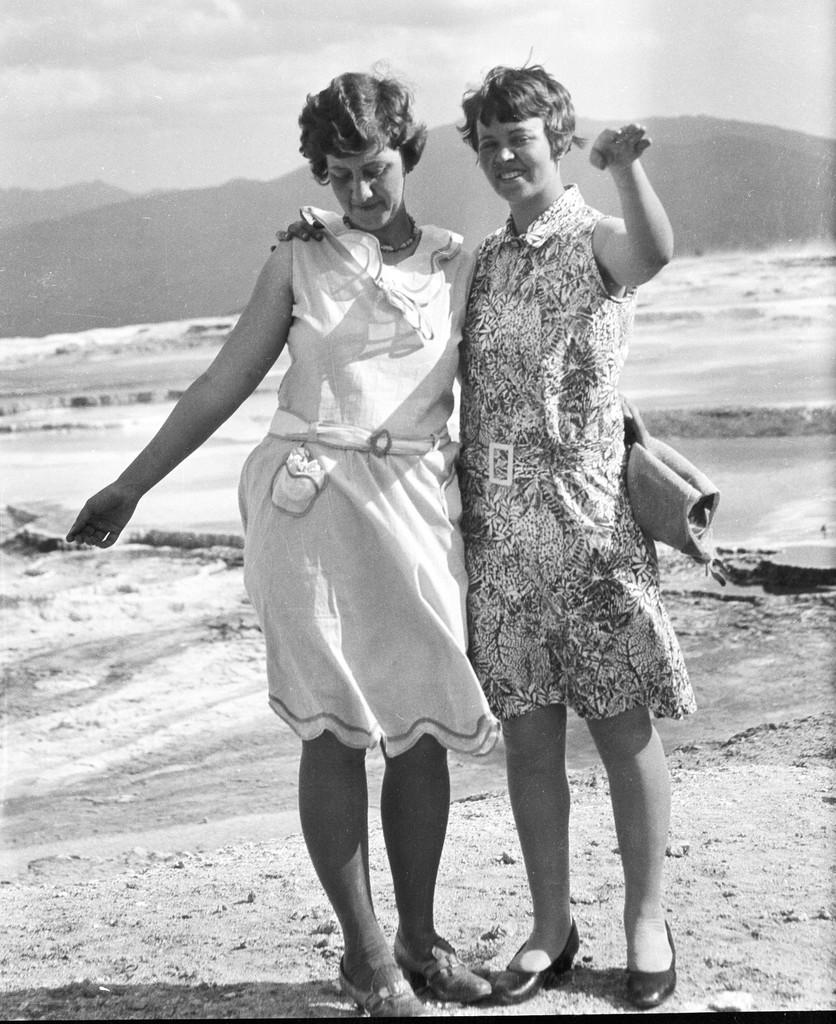How many people are in the image? There are two ladies standing in the center of the image. What can be seen in the background of the image? There is a sea, hills, and the sky visible in the background of the image. What type of gold effect can be seen on the ladies' clothing in the image? There is no mention of a gold effect or any specific clothing details in the image, so it cannot be determined from the image. 